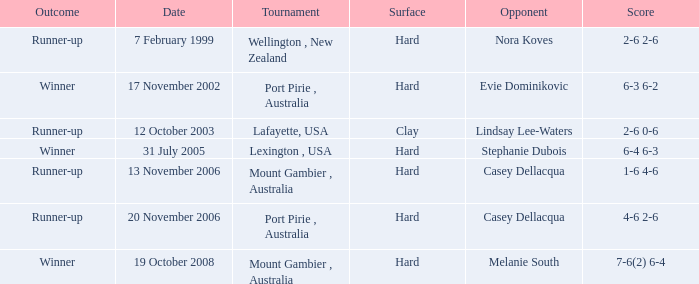Can you provide the outcome for november 13, 2006? Runner-up. Can you parse all the data within this table? {'header': ['Outcome', 'Date', 'Tournament', 'Surface', 'Opponent', 'Score'], 'rows': [['Runner-up', '7 February 1999', 'Wellington , New Zealand', 'Hard', 'Nora Koves', '2-6 2-6'], ['Winner', '17 November 2002', 'Port Pirie , Australia', 'Hard', 'Evie Dominikovic', '6-3 6-2'], ['Runner-up', '12 October 2003', 'Lafayette, USA', 'Clay', 'Lindsay Lee-Waters', '2-6 0-6'], ['Winner', '31 July 2005', 'Lexington , USA', 'Hard', 'Stephanie Dubois', '6-4 6-3'], ['Runner-up', '13 November 2006', 'Mount Gambier , Australia', 'Hard', 'Casey Dellacqua', '1-6 4-6'], ['Runner-up', '20 November 2006', 'Port Pirie , Australia', 'Hard', 'Casey Dellacqua', '4-6 2-6'], ['Winner', '19 October 2008', 'Mount Gambier , Australia', 'Hard', 'Melanie South', '7-6(2) 6-4']]} 